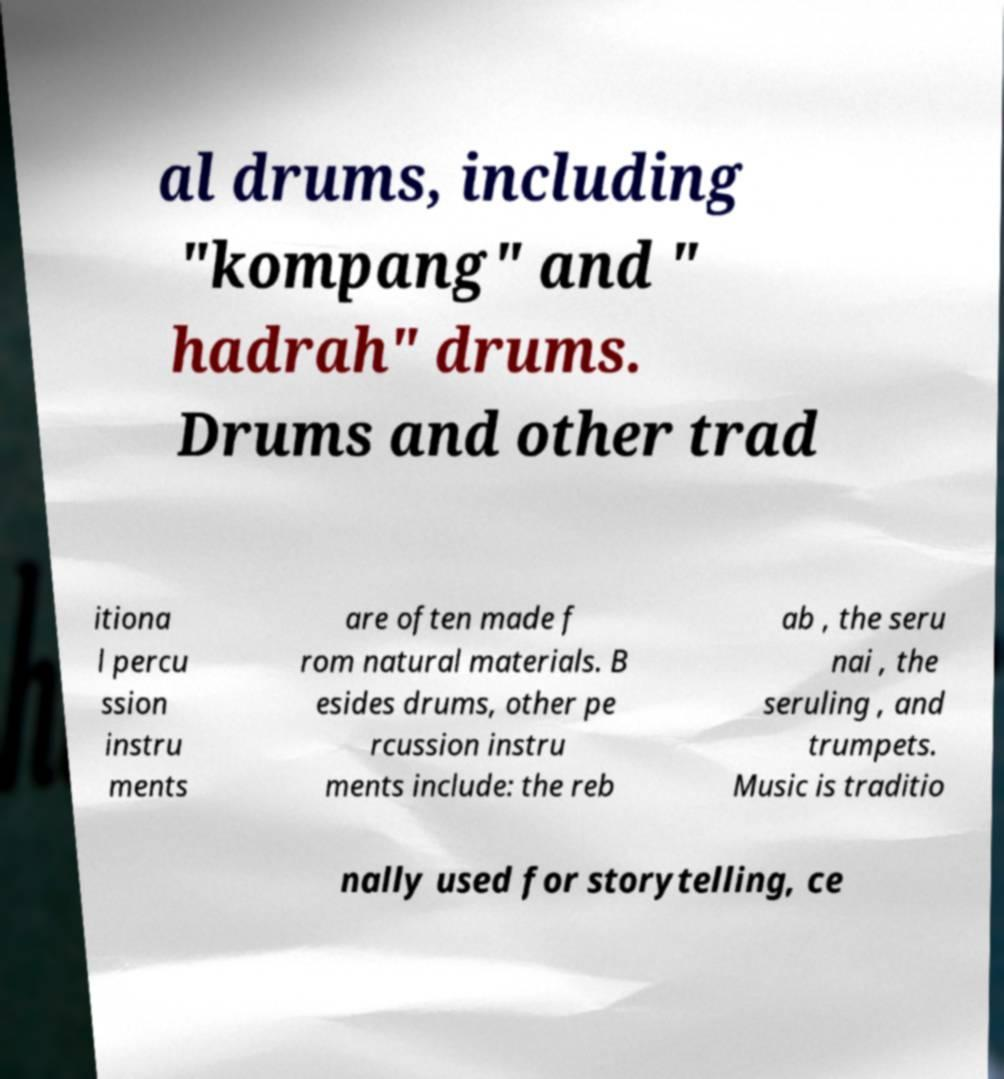Could you assist in decoding the text presented in this image and type it out clearly? al drums, including "kompang" and " hadrah" drums. Drums and other trad itiona l percu ssion instru ments are often made f rom natural materials. B esides drums, other pe rcussion instru ments include: the reb ab , the seru nai , the seruling , and trumpets. Music is traditio nally used for storytelling, ce 